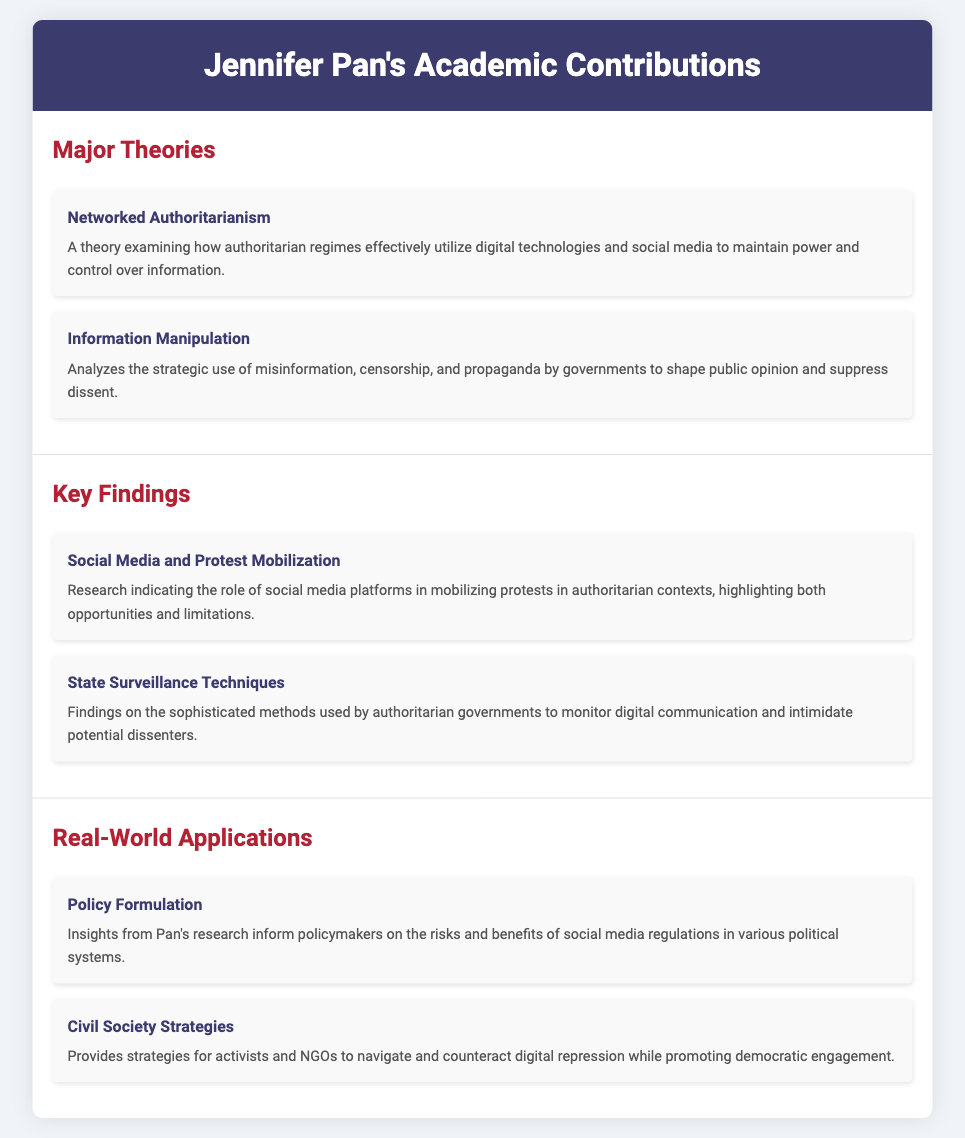What is the first major theory presented? The first major theory listed in the document is "Networked Authoritarianism."
Answer: Networked Authoritarianism What is one key finding related to social media? The document mentions that social media plays a role in protest mobilization in authoritarian contexts.
Answer: Social Media and Protest Mobilization How many major theories are discussed? The document outlines two major theories under the section "Major Theories."
Answer: Two What do insights from Pan's research inform regarding policymakers? The insights inform policymakers on the risks and benefits of social media regulations.
Answer: Social media regulations What is a real-world application mentioned for civil society? A strategy provided is for activists and NGOs to navigate and counteract digital repression.
Answer: Civil Society Strategies What does the "Information Manipulation" theory analyze? It analyzes the strategic use of misinformation, censorship, and propaganda.
Answer: Misinformation, censorship, and propaganda Which key finding discusses state monitoring? The finding on state surveillance techniques addresses methods of monitoring digital communication.
Answer: State Surveillance Techniques What is the main focus of the theory "Information Manipulation"? The theory examines how governments shape public opinion and suppress dissent.
Answer: Suppress dissent 